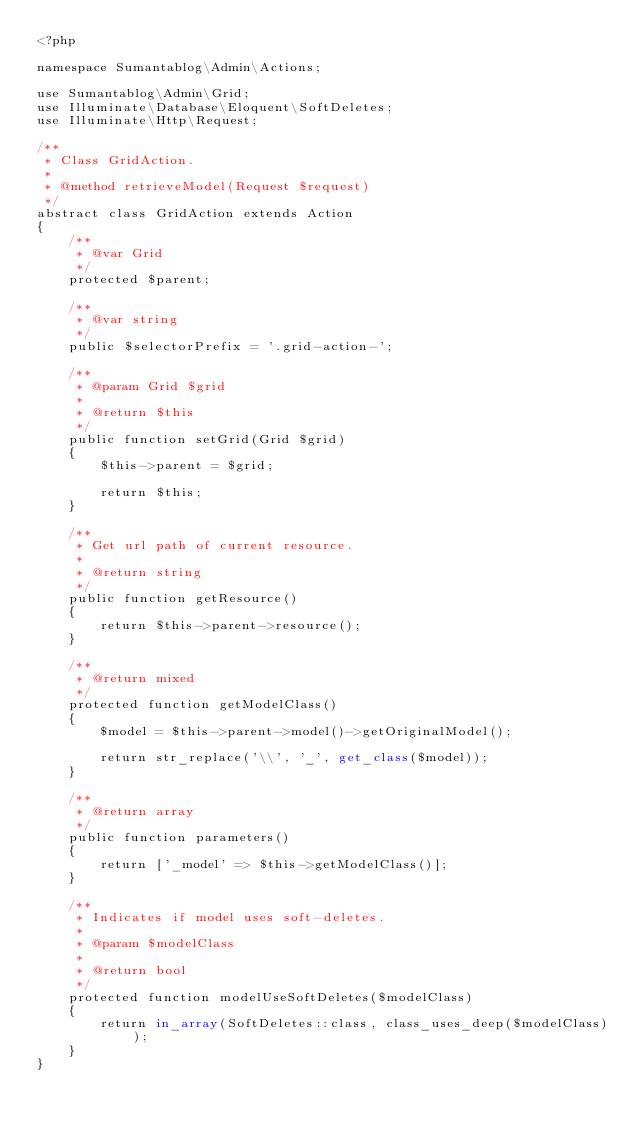<code> <loc_0><loc_0><loc_500><loc_500><_PHP_><?php

namespace Sumantablog\Admin\Actions;

use Sumantablog\Admin\Grid;
use Illuminate\Database\Eloquent\SoftDeletes;
use Illuminate\Http\Request;

/**
 * Class GridAction.
 *
 * @method retrieveModel(Request $request)
 */
abstract class GridAction extends Action
{
    /**
     * @var Grid
     */
    protected $parent;

    /**
     * @var string
     */
    public $selectorPrefix = '.grid-action-';

    /**
     * @param Grid $grid
     *
     * @return $this
     */
    public function setGrid(Grid $grid)
    {
        $this->parent = $grid;

        return $this;
    }

    /**
     * Get url path of current resource.
     *
     * @return string
     */
    public function getResource()
    {
        return $this->parent->resource();
    }

    /**
     * @return mixed
     */
    protected function getModelClass()
    {
        $model = $this->parent->model()->getOriginalModel();

        return str_replace('\\', '_', get_class($model));
    }

    /**
     * @return array
     */
    public function parameters()
    {
        return ['_model' => $this->getModelClass()];
    }

    /**
     * Indicates if model uses soft-deletes.
     *
     * @param $modelClass
     *
     * @return bool
     */
    protected function modelUseSoftDeletes($modelClass)
    {
        return in_array(SoftDeletes::class, class_uses_deep($modelClass));
    }
}
</code> 